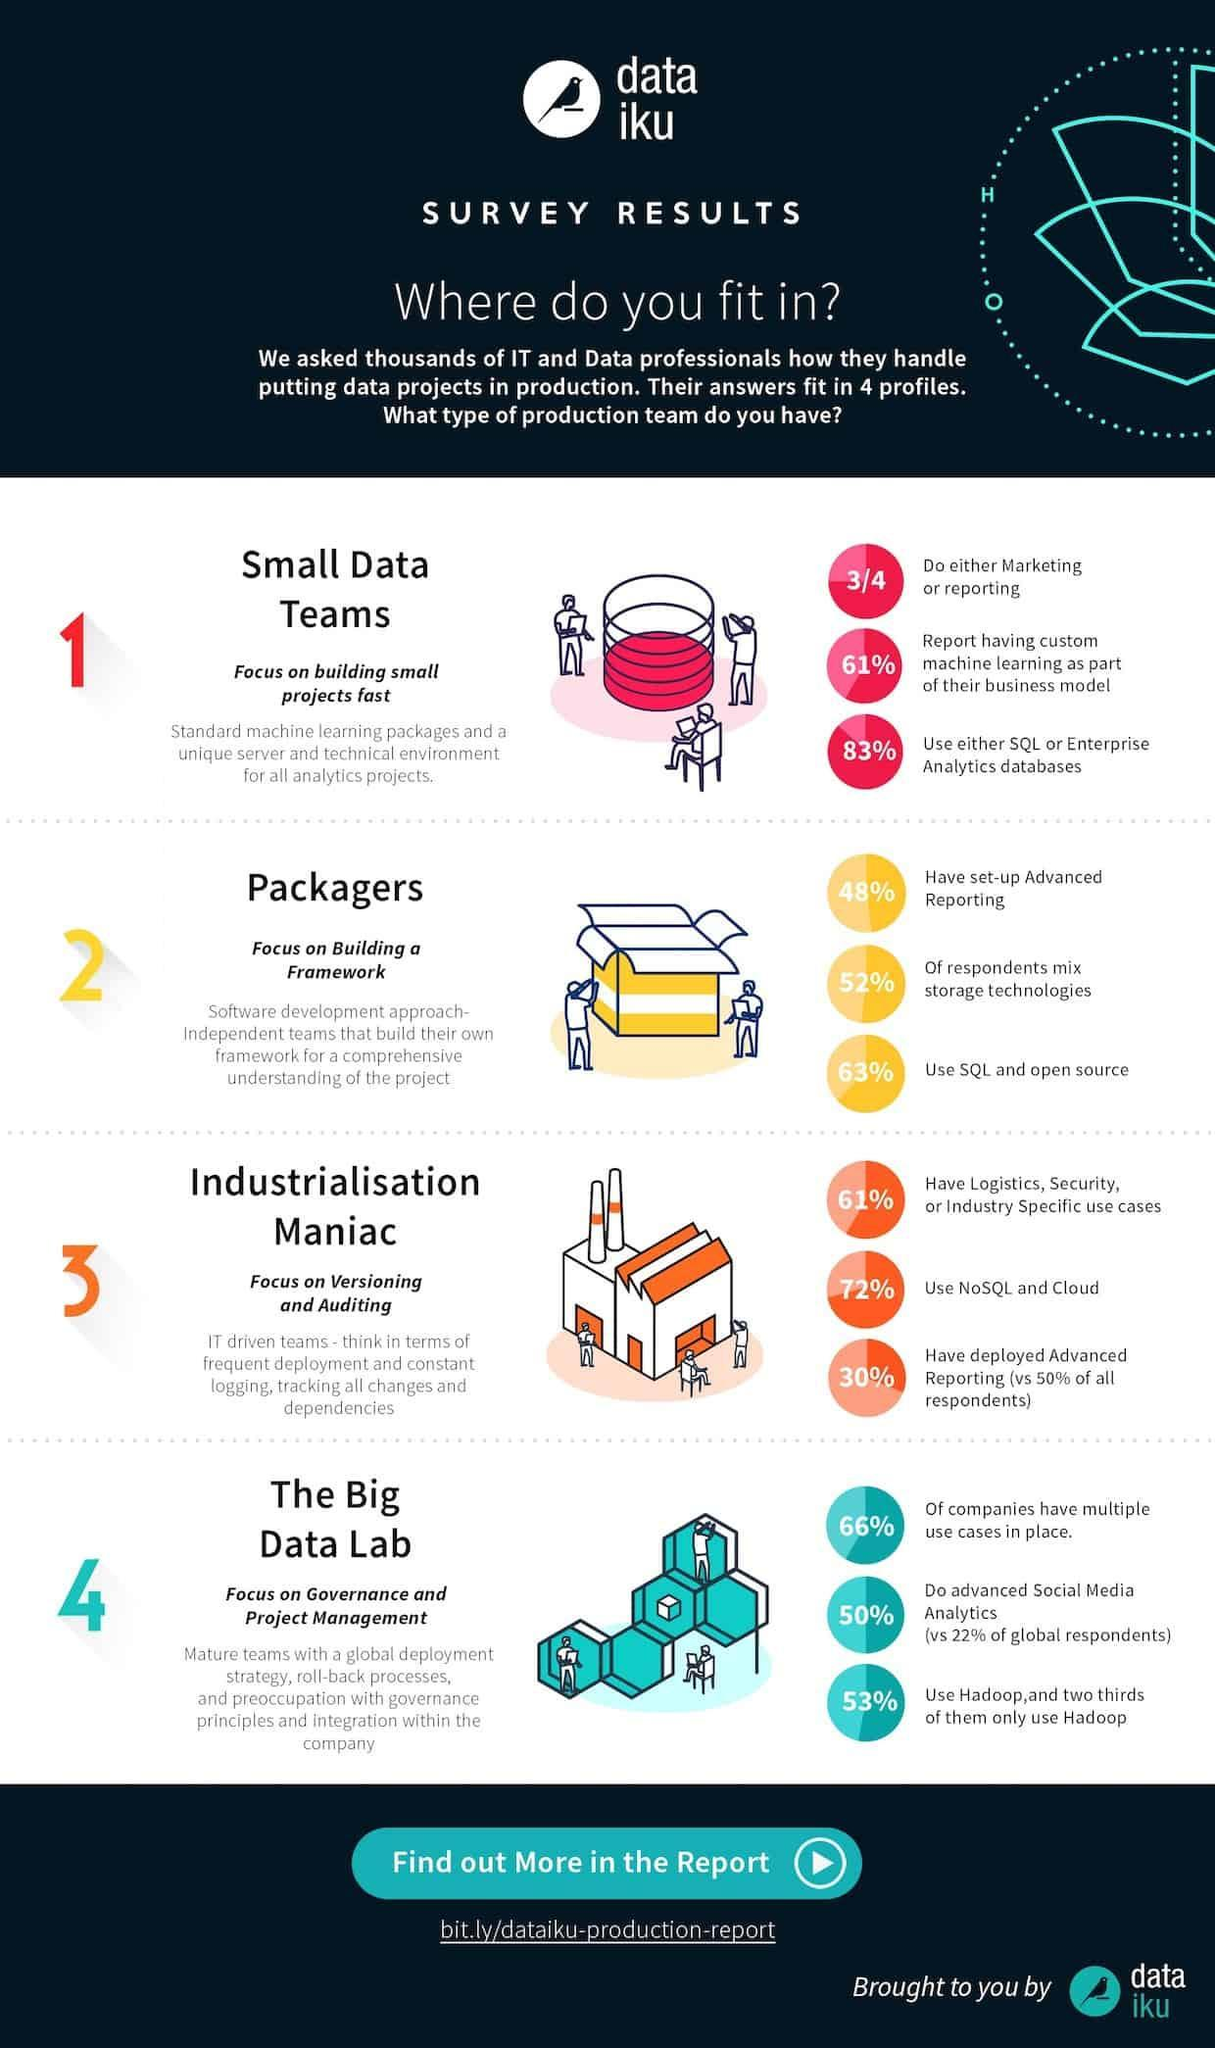What percentage of people have not deployed advanced reporting?
Answer the question with a short phrase. 70% What percentage of people are not using NoSQL and Cloud? 28% What percentage of people are not using SQL and open source? 37% What percentage of people neither uses SQL nor Enterprise Analytics databases? 17% What percentage of people have not set-up advanced reporting? 52% How many people neither do marketing nor reporting? 1\4 What percentage of people are not using Hadoop? 47% What percentage of people have no logistics, security, or industry specific use cases? 39% 